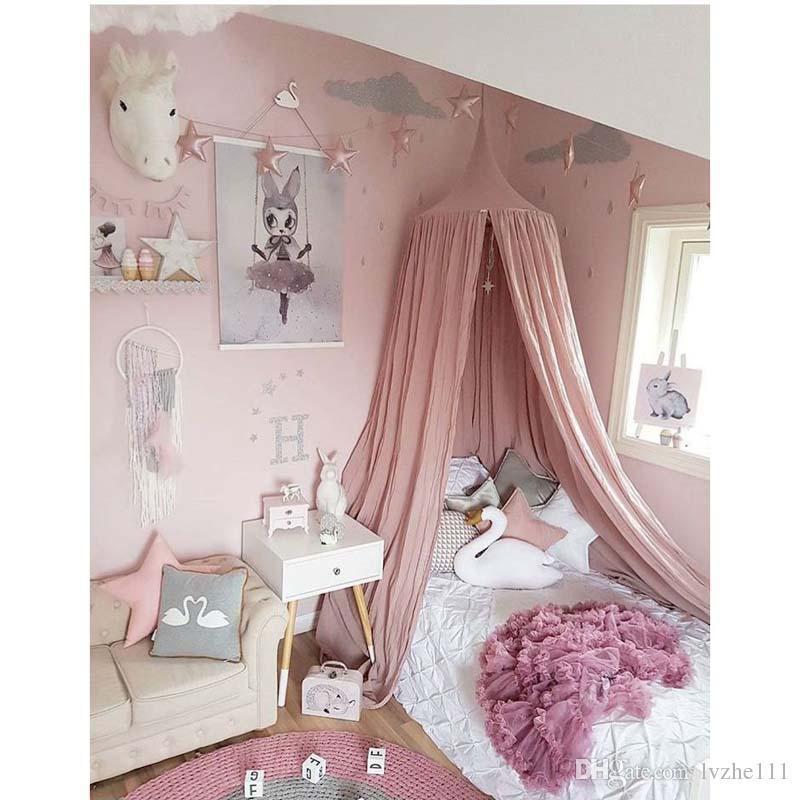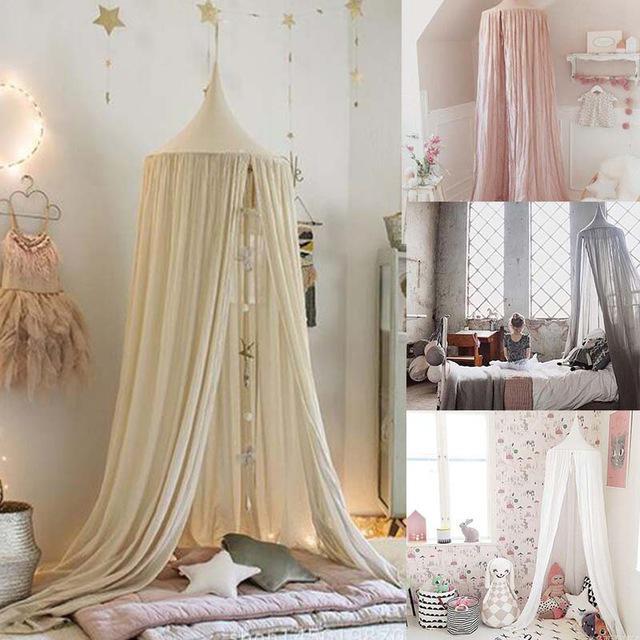The first image is the image on the left, the second image is the image on the right. For the images shown, is this caption "The right image shows a gauzy light gray canopy with a garland of stars hung from the ceiling over a toddler bed with vertical bars and a chair with a plant on its seat next to it." true? Answer yes or no. No. 